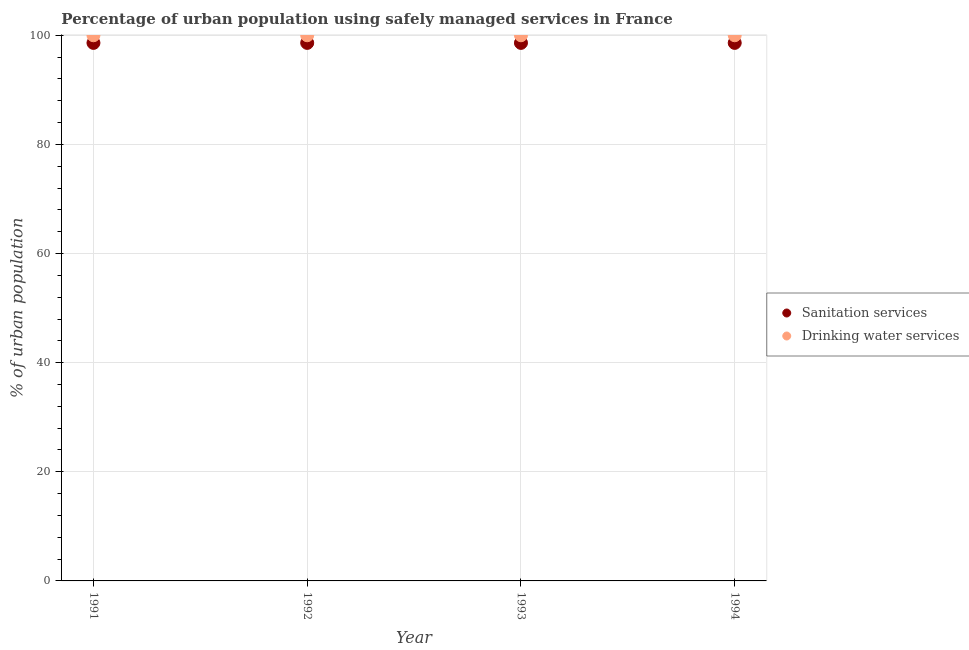What is the percentage of urban population who used drinking water services in 1994?
Keep it short and to the point. 100. Across all years, what is the maximum percentage of urban population who used drinking water services?
Provide a succinct answer. 100. Across all years, what is the minimum percentage of urban population who used drinking water services?
Your answer should be very brief. 100. In which year was the percentage of urban population who used sanitation services maximum?
Your answer should be compact. 1991. In which year was the percentage of urban population who used sanitation services minimum?
Give a very brief answer. 1991. What is the total percentage of urban population who used drinking water services in the graph?
Provide a short and direct response. 400. What is the difference between the percentage of urban population who used sanitation services in 1994 and the percentage of urban population who used drinking water services in 1992?
Keep it short and to the point. -1.4. What is the average percentage of urban population who used sanitation services per year?
Make the answer very short. 98.6. In the year 1993, what is the difference between the percentage of urban population who used sanitation services and percentage of urban population who used drinking water services?
Give a very brief answer. -1.4. Is the percentage of urban population who used sanitation services in 1992 less than that in 1993?
Keep it short and to the point. No. Is the difference between the percentage of urban population who used sanitation services in 1992 and 1993 greater than the difference between the percentage of urban population who used drinking water services in 1992 and 1993?
Provide a short and direct response. No. What is the difference between the highest and the second highest percentage of urban population who used sanitation services?
Your answer should be very brief. 0. What is the difference between the highest and the lowest percentage of urban population who used sanitation services?
Make the answer very short. 0. Does the percentage of urban population who used drinking water services monotonically increase over the years?
Offer a terse response. No. Is the percentage of urban population who used drinking water services strictly greater than the percentage of urban population who used sanitation services over the years?
Make the answer very short. Yes. Is the percentage of urban population who used sanitation services strictly less than the percentage of urban population who used drinking water services over the years?
Make the answer very short. Yes. How many years are there in the graph?
Your answer should be compact. 4. Are the values on the major ticks of Y-axis written in scientific E-notation?
Your response must be concise. No. Does the graph contain any zero values?
Make the answer very short. No. Does the graph contain grids?
Offer a terse response. Yes. How many legend labels are there?
Provide a succinct answer. 2. What is the title of the graph?
Offer a terse response. Percentage of urban population using safely managed services in France. What is the label or title of the Y-axis?
Provide a short and direct response. % of urban population. What is the % of urban population of Sanitation services in 1991?
Keep it short and to the point. 98.6. What is the % of urban population in Drinking water services in 1991?
Offer a terse response. 100. What is the % of urban population of Sanitation services in 1992?
Your answer should be very brief. 98.6. What is the % of urban population in Drinking water services in 1992?
Your answer should be compact. 100. What is the % of urban population of Sanitation services in 1993?
Offer a very short reply. 98.6. What is the % of urban population in Drinking water services in 1993?
Give a very brief answer. 100. What is the % of urban population of Sanitation services in 1994?
Offer a terse response. 98.6. Across all years, what is the maximum % of urban population of Sanitation services?
Offer a very short reply. 98.6. Across all years, what is the maximum % of urban population in Drinking water services?
Give a very brief answer. 100. Across all years, what is the minimum % of urban population of Sanitation services?
Offer a terse response. 98.6. Across all years, what is the minimum % of urban population in Drinking water services?
Provide a succinct answer. 100. What is the total % of urban population in Sanitation services in the graph?
Keep it short and to the point. 394.4. What is the difference between the % of urban population of Sanitation services in 1991 and that in 1994?
Provide a succinct answer. 0. What is the difference between the % of urban population in Sanitation services in 1993 and that in 1994?
Provide a short and direct response. 0. What is the difference between the % of urban population in Drinking water services in 1993 and that in 1994?
Your response must be concise. 0. What is the difference between the % of urban population in Sanitation services in 1991 and the % of urban population in Drinking water services in 1993?
Offer a terse response. -1.4. What is the average % of urban population of Sanitation services per year?
Offer a very short reply. 98.6. In the year 1992, what is the difference between the % of urban population of Sanitation services and % of urban population of Drinking water services?
Ensure brevity in your answer.  -1.4. In the year 1993, what is the difference between the % of urban population of Sanitation services and % of urban population of Drinking water services?
Your answer should be very brief. -1.4. What is the ratio of the % of urban population in Drinking water services in 1991 to that in 1992?
Offer a terse response. 1. What is the ratio of the % of urban population of Sanitation services in 1991 to that in 1993?
Offer a very short reply. 1. What is the ratio of the % of urban population in Drinking water services in 1991 to that in 1994?
Your answer should be very brief. 1. What is the ratio of the % of urban population in Drinking water services in 1992 to that in 1993?
Ensure brevity in your answer.  1. What is the ratio of the % of urban population in Drinking water services in 1992 to that in 1994?
Offer a very short reply. 1. What is the ratio of the % of urban population in Sanitation services in 1993 to that in 1994?
Keep it short and to the point. 1. What is the difference between the highest and the second highest % of urban population in Sanitation services?
Provide a succinct answer. 0. What is the difference between the highest and the second highest % of urban population in Drinking water services?
Ensure brevity in your answer.  0. What is the difference between the highest and the lowest % of urban population of Drinking water services?
Offer a terse response. 0. 